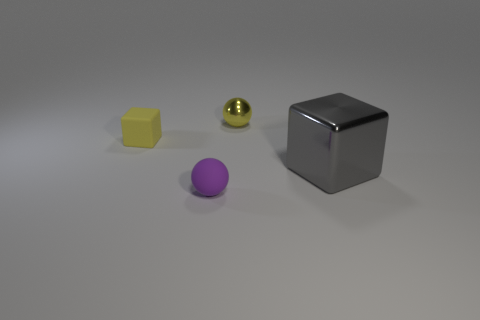Add 1 blue metallic cylinders. How many objects exist? 5 Subtract all brown cubes. Subtract all red cylinders. How many cubes are left? 2 Subtract all green balls. How many blue blocks are left? 0 Subtract all blue shiny spheres. Subtract all tiny blocks. How many objects are left? 3 Add 3 yellow objects. How many yellow objects are left? 5 Add 2 tiny yellow metallic spheres. How many tiny yellow metallic spheres exist? 3 Subtract 0 red balls. How many objects are left? 4 